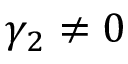Convert formula to latex. <formula><loc_0><loc_0><loc_500><loc_500>\gamma _ { 2 } \neq 0</formula> 